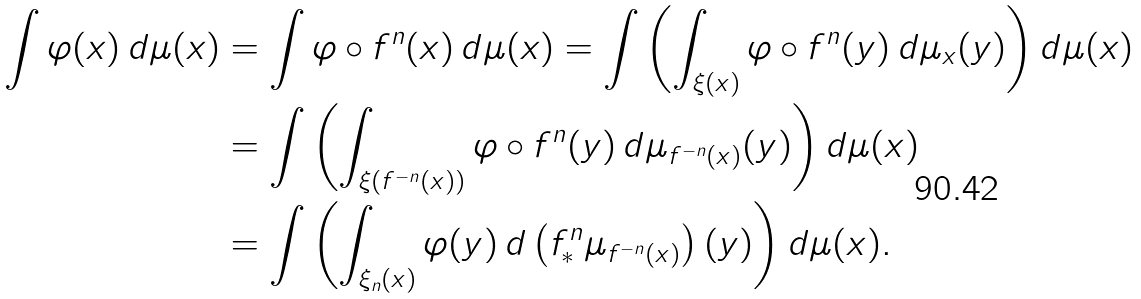Convert formula to latex. <formula><loc_0><loc_0><loc_500><loc_500>\int \varphi ( x ) \, d \mu ( x ) & = \int \varphi \circ f ^ { n } ( x ) \, d \mu ( x ) = \int \left ( \int _ { \xi ( x ) } \varphi \circ f ^ { n } ( y ) \, d \mu _ { x } ( y ) \right ) d \mu ( x ) \\ & = \int \left ( \int _ { \xi ( f ^ { - n } ( x ) ) } \varphi \circ f ^ { n } ( y ) \, d \mu _ { f ^ { - n } ( x ) } ( y ) \right ) d \mu ( x ) \\ & = \int \left ( \int _ { \xi _ { n } ( x ) } \varphi ( y ) \, d \left ( f ^ { n } _ { \ast } \mu _ { f ^ { - n } ( x ) } \right ) ( y ) \right ) d \mu ( x ) .</formula> 